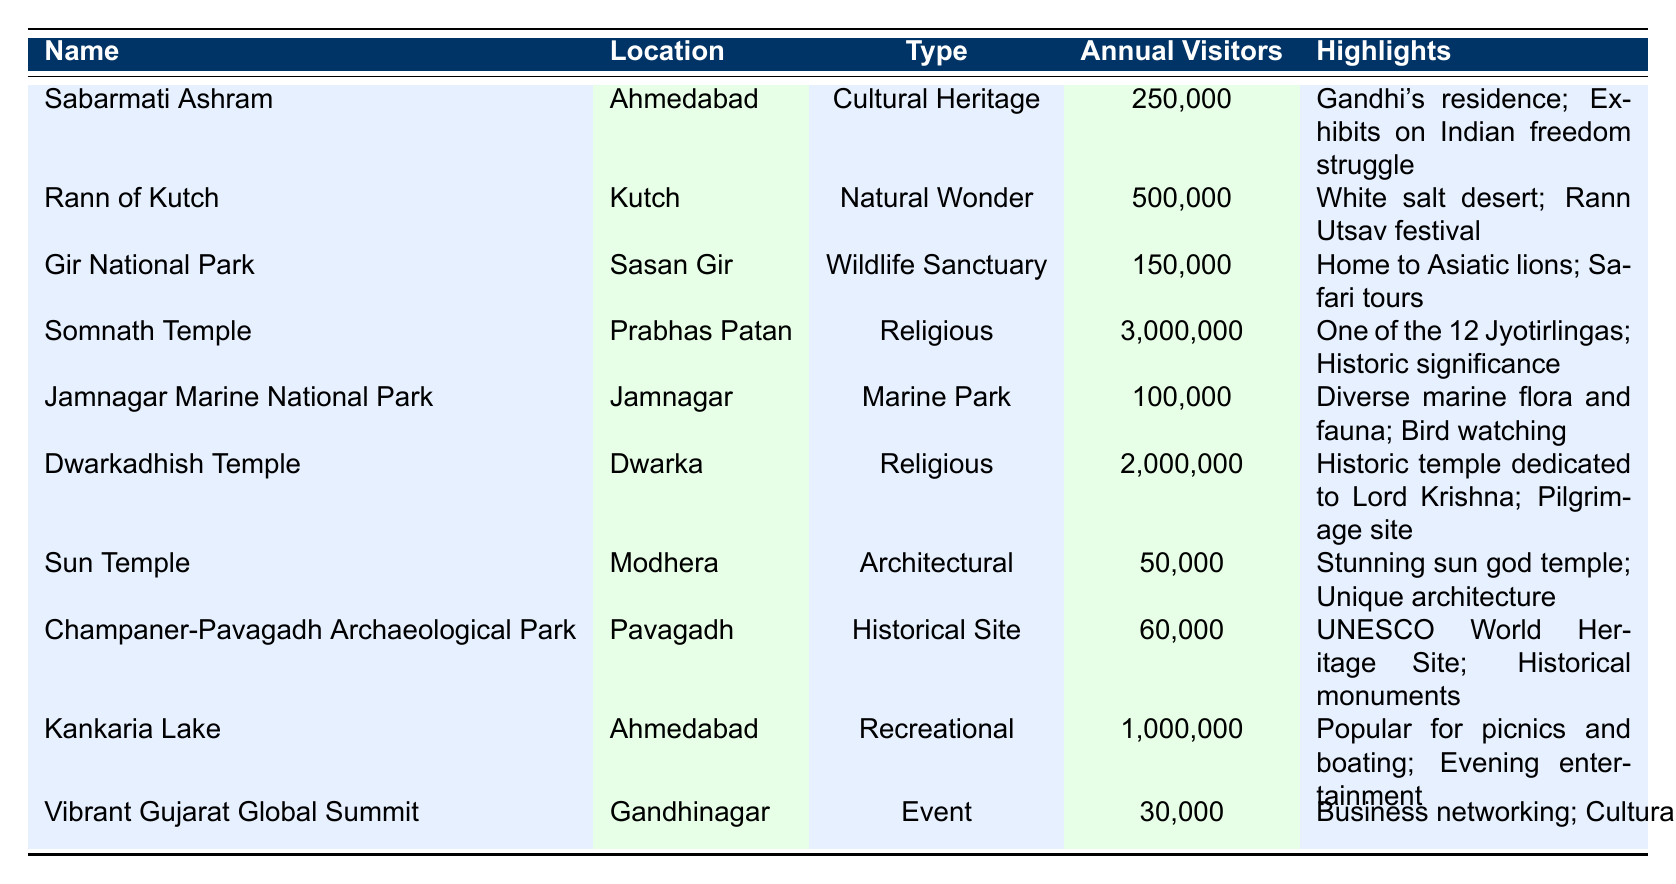What is the type of the Sabarmati Ashram? The table indicates that the type of Sabarmati Ashram is listed as "Cultural Heritage".
Answer: Cultural Heritage Which tourist attraction has the highest average annual visitors? By comparing the annual visitor numbers, Somnath Temple has the highest at 3,000,000 visitors.
Answer: Somnath Temple How many more visitors does the Rann of Kutch have compared to Gir National Park? Rann of Kutch has 500,000 visitors and Gir National Park has 150,000 visitors. Therefore, the difference is 500,000 - 150,000 = 350,000.
Answer: 350,000 Is the Sun Temple the least visited attraction according to the table? The average annual visitors for the Sun Temple is 50,000, which is lower than all other attractions listed in the table, confirming it is the least visited.
Answer: Yes What is the total number of average visitors for the two religious attractions listed? Summing up the average annual visitors for Somnath Temple (3,000,000) and Dwarkadhish Temple (2,000,000) gives 3,000,000 + 2,000,000 = 5,000,000.
Answer: 5,000,000 Which attraction in Ahmedabad has the most annual visitors? In Ahmedabad, the Kankaria Lake with 1,000,000 visitors has the highest number compared to Sabarmati Ashram (250,000).
Answer: Kankaria Lake Does Jamnagar Marine National Park have more visitors than the Champaner-Pavagadh Archaeological Park? The table shows Jamnagar Marine National Park has 100,000 visitors while Champaner-Pavagadh Archaeological Park has 60,000 visitors, indicating that Jamnagar Marine National Park has more.
Answer: Yes What is the average number of visitors for recreational attractions in Gujarat? The only recreational attraction listed is Kankaria Lake with 1,000,000 visitors, thus the average is simply 1,000,000.
Answer: 1,000,000 How many visitors are attracted to the Vibrant Gujarat Global Summit? The table indicates that the Vibrant Gujarat Global Summit attracts an average of 30,000 visitors annually.
Answer: 30,000 